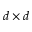Convert formula to latex. <formula><loc_0><loc_0><loc_500><loc_500>d \times d</formula> 